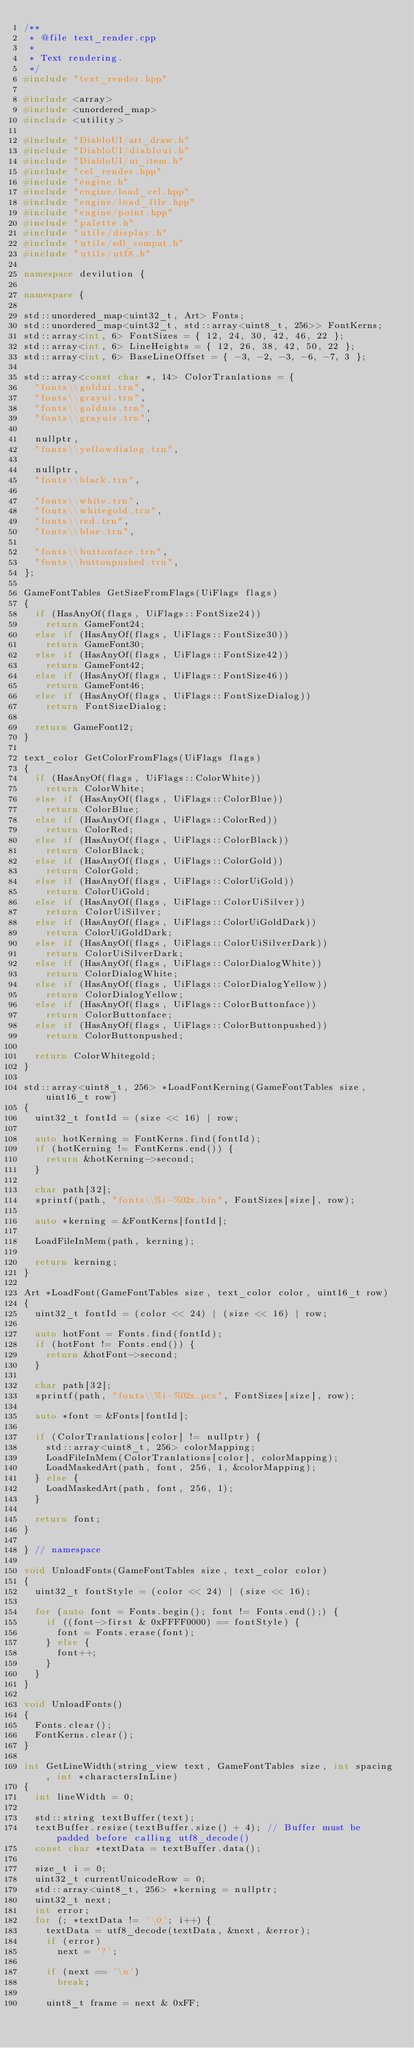<code> <loc_0><loc_0><loc_500><loc_500><_C++_>/**
 * @file text_render.cpp
 *
 * Text rendering.
 */
#include "text_render.hpp"

#include <array>
#include <unordered_map>
#include <utility>

#include "DiabloUI/art_draw.h"
#include "DiabloUI/diabloui.h"
#include "DiabloUI/ui_item.h"
#include "cel_render.hpp"
#include "engine.h"
#include "engine/load_cel.hpp"
#include "engine/load_file.hpp"
#include "engine/point.hpp"
#include "palette.h"
#include "utils/display.h"
#include "utils/sdl_compat.h"
#include "utils/utf8.h"

namespace devilution {

namespace {

std::unordered_map<uint32_t, Art> Fonts;
std::unordered_map<uint32_t, std::array<uint8_t, 256>> FontKerns;
std::array<int, 6> FontSizes = { 12, 24, 30, 42, 46, 22 };
std::array<int, 6> LineHeights = { 12, 26, 38, 42, 50, 22 };
std::array<int, 6> BaseLineOffset = { -3, -2, -3, -6, -7, 3 };

std::array<const char *, 14> ColorTranlations = {
	"fonts\\goldui.trn",
	"fonts\\grayui.trn",
	"fonts\\golduis.trn",
	"fonts\\grayuis.trn",

	nullptr,
	"fonts\\yellowdialog.trn",

	nullptr,
	"fonts\\black.trn",

	"fonts\\white.trn",
	"fonts\\whitegold.trn",
	"fonts\\red.trn",
	"fonts\\blue.trn",

	"fonts\\buttonface.trn",
	"fonts\\buttonpushed.trn",
};

GameFontTables GetSizeFromFlags(UiFlags flags)
{
	if (HasAnyOf(flags, UiFlags::FontSize24))
		return GameFont24;
	else if (HasAnyOf(flags, UiFlags::FontSize30))
		return GameFont30;
	else if (HasAnyOf(flags, UiFlags::FontSize42))
		return GameFont42;
	else if (HasAnyOf(flags, UiFlags::FontSize46))
		return GameFont46;
	else if (HasAnyOf(flags, UiFlags::FontSizeDialog))
		return FontSizeDialog;

	return GameFont12;
}

text_color GetColorFromFlags(UiFlags flags)
{
	if (HasAnyOf(flags, UiFlags::ColorWhite))
		return ColorWhite;
	else if (HasAnyOf(flags, UiFlags::ColorBlue))
		return ColorBlue;
	else if (HasAnyOf(flags, UiFlags::ColorRed))
		return ColorRed;
	else if (HasAnyOf(flags, UiFlags::ColorBlack))
		return ColorBlack;
	else if (HasAnyOf(flags, UiFlags::ColorGold))
		return ColorGold;
	else if (HasAnyOf(flags, UiFlags::ColorUiGold))
		return ColorUiGold;
	else if (HasAnyOf(flags, UiFlags::ColorUiSilver))
		return ColorUiSilver;
	else if (HasAnyOf(flags, UiFlags::ColorUiGoldDark))
		return ColorUiGoldDark;
	else if (HasAnyOf(flags, UiFlags::ColorUiSilverDark))
		return ColorUiSilverDark;
	else if (HasAnyOf(flags, UiFlags::ColorDialogWhite))
		return ColorDialogWhite;
	else if (HasAnyOf(flags, UiFlags::ColorDialogYellow))
		return ColorDialogYellow;
	else if (HasAnyOf(flags, UiFlags::ColorButtonface))
		return ColorButtonface;
	else if (HasAnyOf(flags, UiFlags::ColorButtonpushed))
		return ColorButtonpushed;

	return ColorWhitegold;
}

std::array<uint8_t, 256> *LoadFontKerning(GameFontTables size, uint16_t row)
{
	uint32_t fontId = (size << 16) | row;

	auto hotKerning = FontKerns.find(fontId);
	if (hotKerning != FontKerns.end()) {
		return &hotKerning->second;
	}

	char path[32];
	sprintf(path, "fonts\\%i-%02x.bin", FontSizes[size], row);

	auto *kerning = &FontKerns[fontId];

	LoadFileInMem(path, kerning);

	return kerning;
}

Art *LoadFont(GameFontTables size, text_color color, uint16_t row)
{
	uint32_t fontId = (color << 24) | (size << 16) | row;

	auto hotFont = Fonts.find(fontId);
	if (hotFont != Fonts.end()) {
		return &hotFont->second;
	}

	char path[32];
	sprintf(path, "fonts\\%i-%02x.pcx", FontSizes[size], row);

	auto *font = &Fonts[fontId];

	if (ColorTranlations[color] != nullptr) {
		std::array<uint8_t, 256> colorMapping;
		LoadFileInMem(ColorTranlations[color], colorMapping);
		LoadMaskedArt(path, font, 256, 1, &colorMapping);
	} else {
		LoadMaskedArt(path, font, 256, 1);
	}

	return font;
}

} // namespace

void UnloadFonts(GameFontTables size, text_color color)
{
	uint32_t fontStyle = (color << 24) | (size << 16);

	for (auto font = Fonts.begin(); font != Fonts.end();) {
		if ((font->first & 0xFFFF0000) == fontStyle) {
			font = Fonts.erase(font);
		} else {
			font++;
		}
	}
}

void UnloadFonts()
{
	Fonts.clear();
	FontKerns.clear();
}

int GetLineWidth(string_view text, GameFontTables size, int spacing, int *charactersInLine)
{
	int lineWidth = 0;

	std::string textBuffer(text);
	textBuffer.resize(textBuffer.size() + 4); // Buffer must be padded before calling utf8_decode()
	const char *textData = textBuffer.data();

	size_t i = 0;
	uint32_t currentUnicodeRow = 0;
	std::array<uint8_t, 256> *kerning = nullptr;
	uint32_t next;
	int error;
	for (; *textData != '\0'; i++) {
		textData = utf8_decode(textData, &next, &error);
		if (error)
			next = '?';

		if (next == '\n')
			break;

		uint8_t frame = next & 0xFF;</code> 